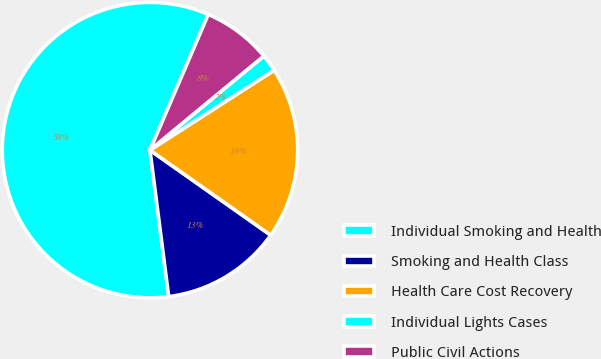Convert chart to OTSL. <chart><loc_0><loc_0><loc_500><loc_500><pie_chart><fcel>Individual Smoking and Health<fcel>Smoking and Health Class<fcel>Health Care Cost Recovery<fcel>Individual Lights Cases<fcel>Public Civil Actions<nl><fcel>58.49%<fcel>13.21%<fcel>18.87%<fcel>1.89%<fcel>7.55%<nl></chart> 